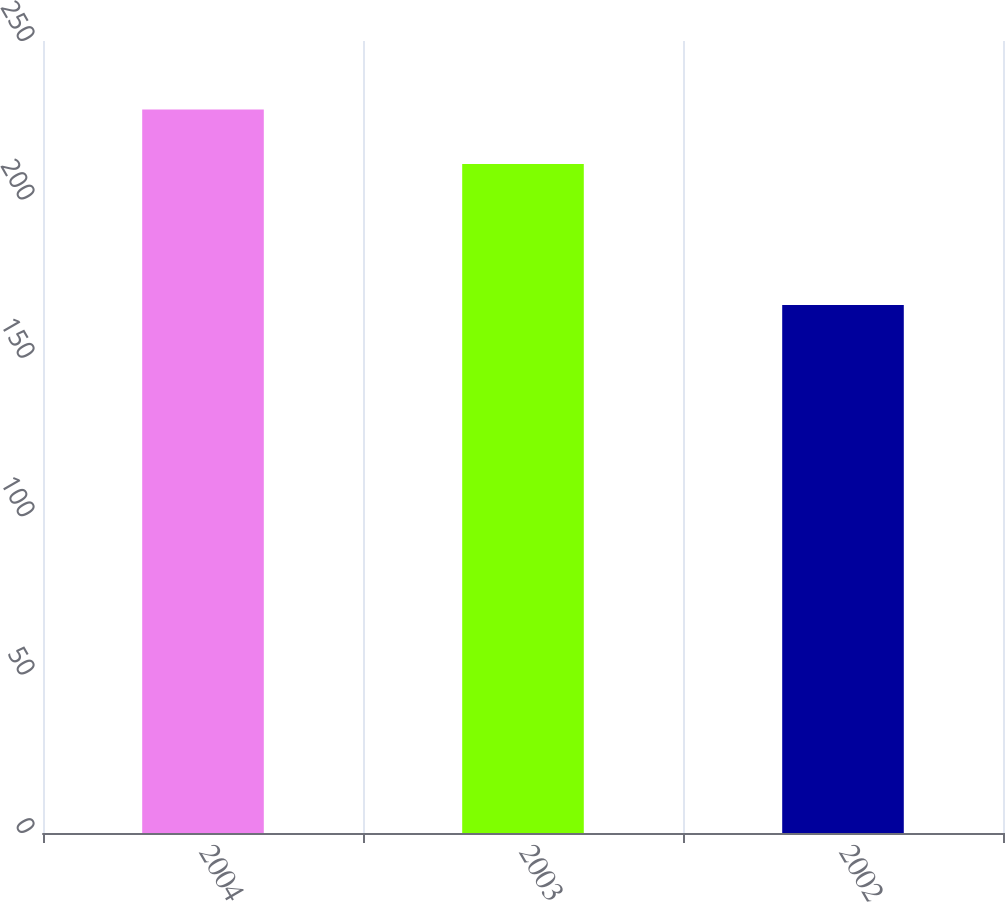<chart> <loc_0><loc_0><loc_500><loc_500><bar_chart><fcel>2004<fcel>2003<fcel>2002<nl><fcel>228.4<fcel>211.2<fcel>166.7<nl></chart> 